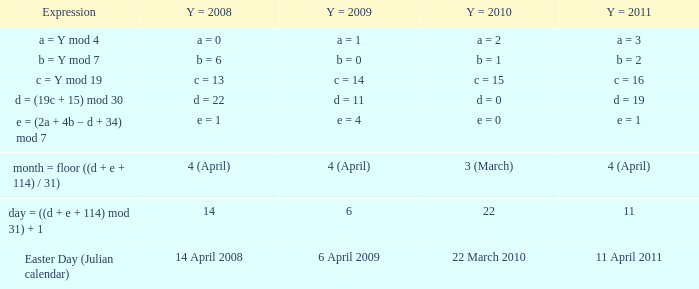What is the y = 2008 when y = 2011 is equivalent to a = 3? A = 0. 